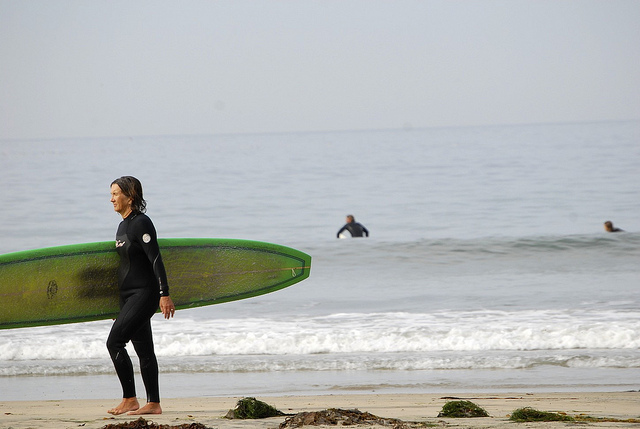What are the surfers likely feeling or thinking as they engage with the waves? The surfers are likely feeling a mix of excitement, focus, and anticipation. Engaging with the waves requires concentration, and they might be mentally assessing the timing and pattern of the waves. The person in the foreground might be feeling eager to join the others and experience the thrill of riding the waves. Those already in the water could be in a state of alert readiness, waiting for the perfect moment to catch a wave. There's also a sense of connection with nature, as they attune themselves to the movements of the ocean. What could be the conversation among the surfers during their session? During their session, the surfers might be exchanging tips about the best spots to catch waves, commenting on the current conditions, or sharing excitement about their day. Conversations could include: 'The waves are picking up around that point, let's head over there,' 'Remember that perfect wave I caught last session? Hoping for the sharegpt4v/same today,' or 'How’s the water feeling today? A bit chilly, but perfect for surfing.' They might also discuss surfing techniques or reminisce about past surfing experiences. Visualize a scenario where all three surfers meet at a beach bonfire after their session. What would they talk about? Around a beach bonfire, the three surfers would likely reflect on their session, sharing the highs and lows of the day's surf. They might recount their best waves, laugh about any wipeouts, and discuss their impressions of the ocean conditions. The conversation could drift to more personal topics, such as future surfing trips, life challenges, or upcoming plans. With the sound of crackling firewood and crashing waves in the background, they might also reminisce about how they started surfing, the bonds they've formed through the sport, and their dreams for future adventures. The warmth of the fire, the starry night sky, and the camaraderie among friends would create a perfect backdrop for deep and meaningful conversation. 